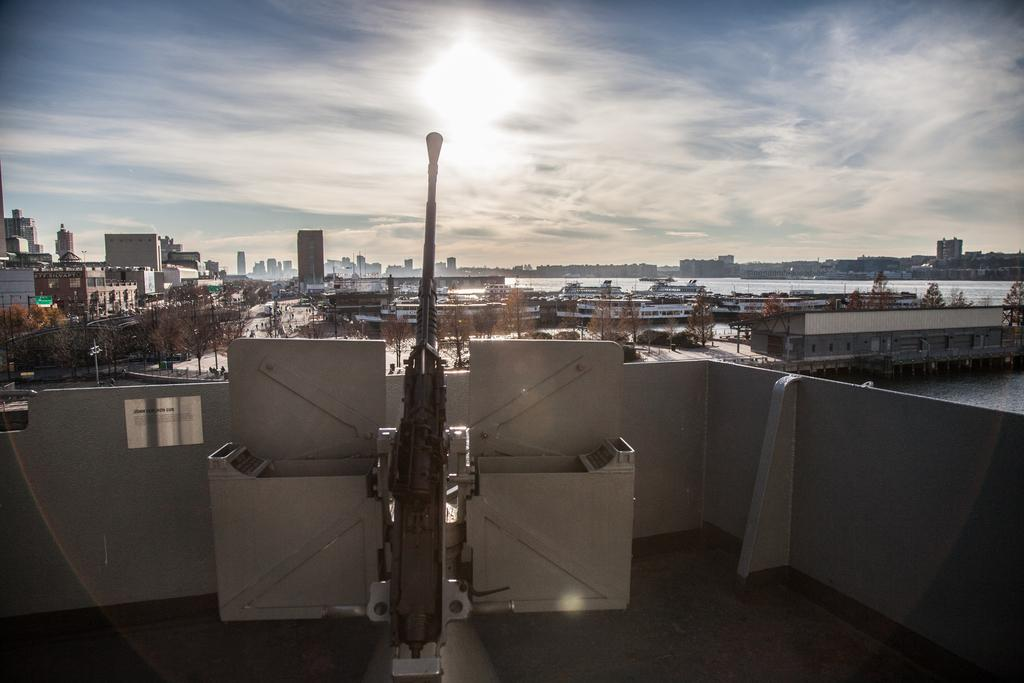What is located in the center of the image? There are trees in the center of the image. What can be seen in the background of the image? There are buildings in the background of the image. What color are the objects in the front of the image? The objects in the front of the image are cream in color. How would you describe the sky in the image? The sky is cloudy in the image. What type of jam is being spread on the fork in the image? There is no fork or jam present in the image. What system is being used to organize the trees in the image? There is no system being used to organize the trees in the image; they are naturally growing. 